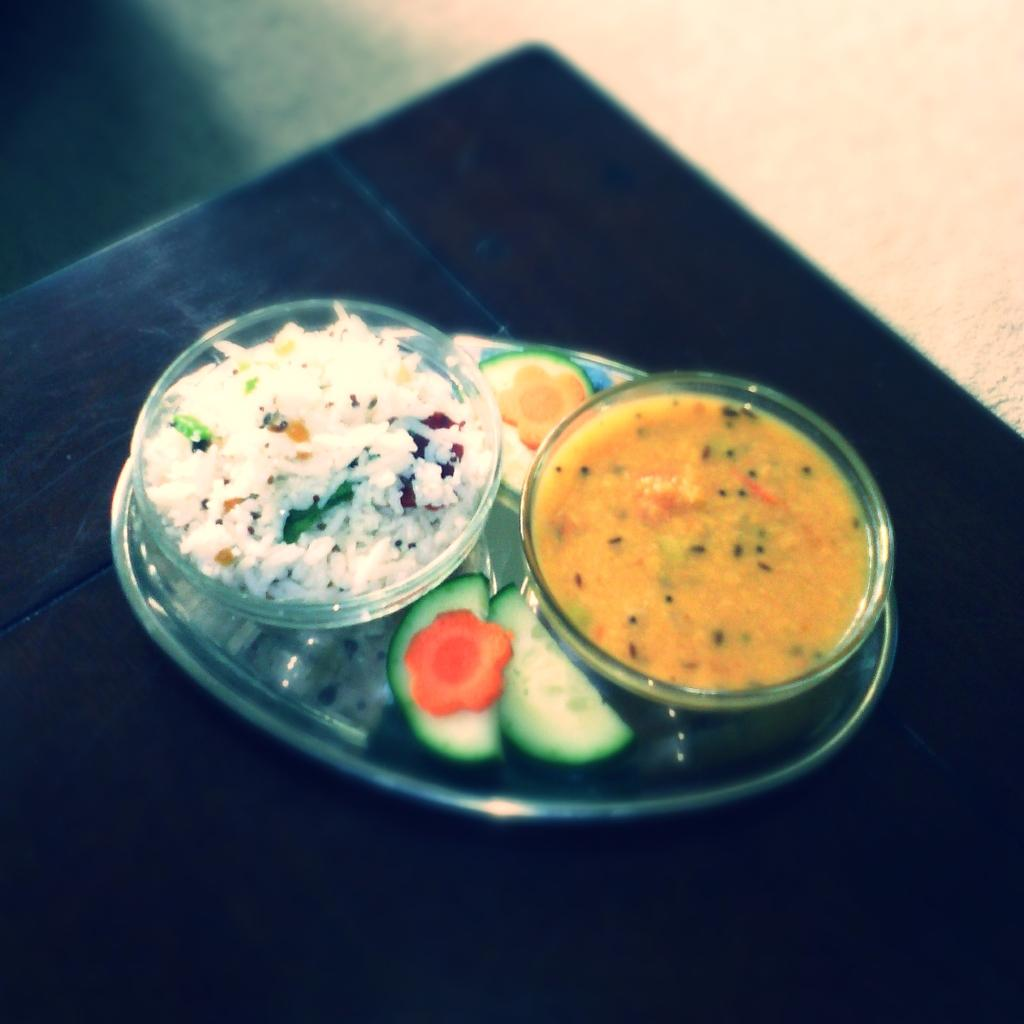What is on the plate that is visible in the image? There is food on a plate in the image. Where is the plate located in the image? The plate is in the center of the image. How many stitches are visible on the food in the image? There are no stitches visible on the food in the image, as stitches are not a characteristic of food. 